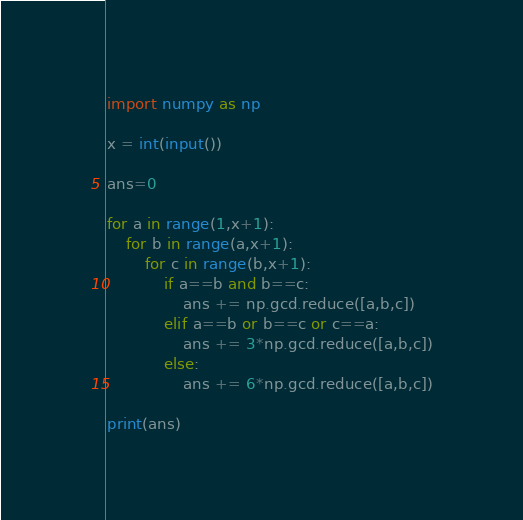Convert code to text. <code><loc_0><loc_0><loc_500><loc_500><_Python_>import numpy as np

x = int(input())

ans=0

for a in range(1,x+1):
    for b in range(a,x+1):
        for c in range(b,x+1):
            if a==b and b==c:
                ans += np.gcd.reduce([a,b,c])
            elif a==b or b==c or c==a:
                ans += 3*np.gcd.reduce([a,b,c])
            else:
                ans += 6*np.gcd.reduce([a,b,c])

print(ans)</code> 